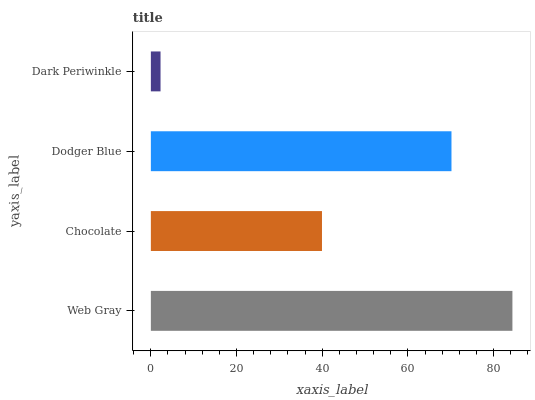Is Dark Periwinkle the minimum?
Answer yes or no. Yes. Is Web Gray the maximum?
Answer yes or no. Yes. Is Chocolate the minimum?
Answer yes or no. No. Is Chocolate the maximum?
Answer yes or no. No. Is Web Gray greater than Chocolate?
Answer yes or no. Yes. Is Chocolate less than Web Gray?
Answer yes or no. Yes. Is Chocolate greater than Web Gray?
Answer yes or no. No. Is Web Gray less than Chocolate?
Answer yes or no. No. Is Dodger Blue the high median?
Answer yes or no. Yes. Is Chocolate the low median?
Answer yes or no. Yes. Is Web Gray the high median?
Answer yes or no. No. Is Web Gray the low median?
Answer yes or no. No. 